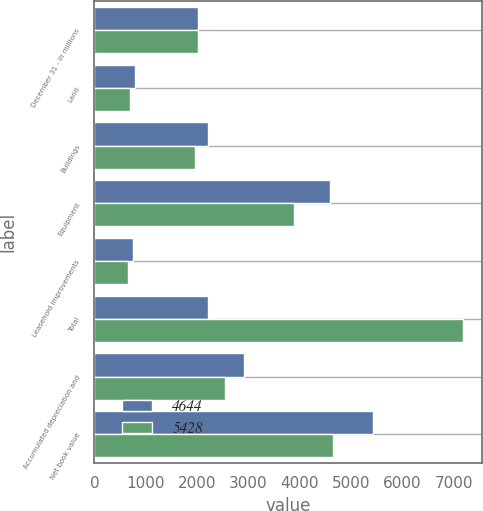<chart> <loc_0><loc_0><loc_500><loc_500><stacked_bar_chart><ecel><fcel>December 31 - in millions<fcel>Land<fcel>Buildings<fcel>Equipment<fcel>Leasehold improvements<fcel>Total<fcel>Accumulated depreciation and<fcel>Net book value<nl><fcel>4644<fcel>2012<fcel>782<fcel>2218<fcel>4590<fcel>747<fcel>2218<fcel>2909<fcel>5428<nl><fcel>5428<fcel>2011<fcel>690<fcel>1955<fcel>3894<fcel>651<fcel>7190<fcel>2546<fcel>4644<nl></chart> 